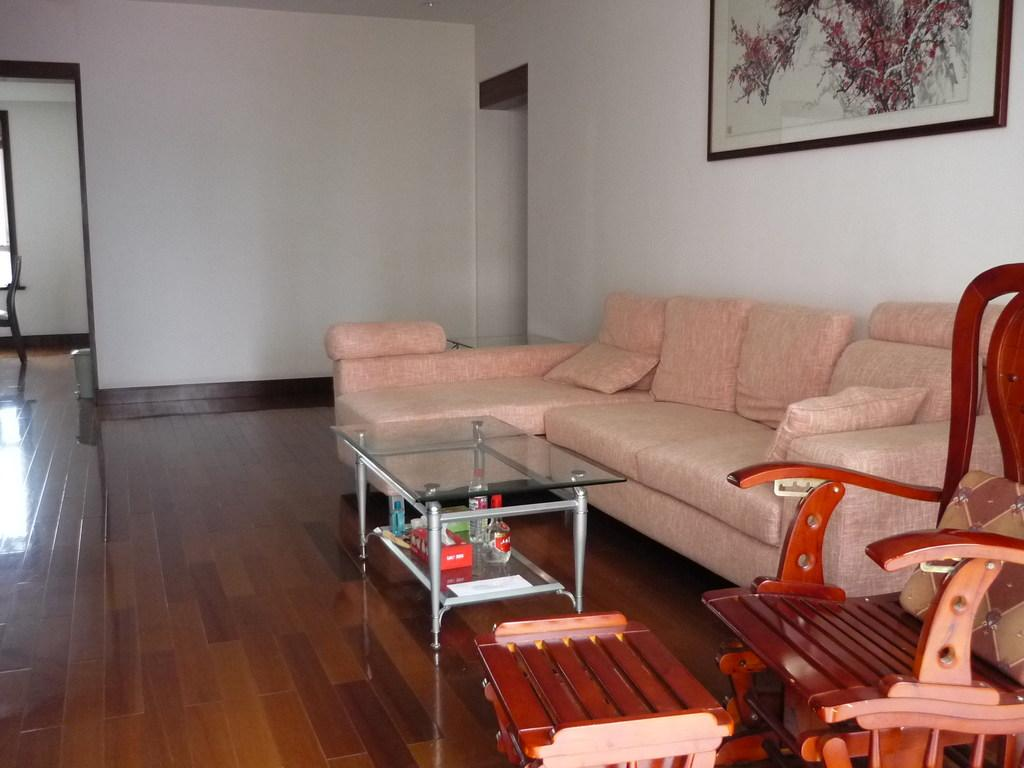What type of space is depicted in the image? The image is of the inside of a room. What furniture can be seen in the room? There is a sofa, a table, and a chair on the floor in the room. Is there any decoration on the wall in the room? Yes, there is a frame on the wall in the room. Can you tell me how many guitars are leaning against the chair in the image? There are no guitars present in the image. Is there a body of water in the room where someone can swim? There is no body of water or swimming activity depicted in the image. 